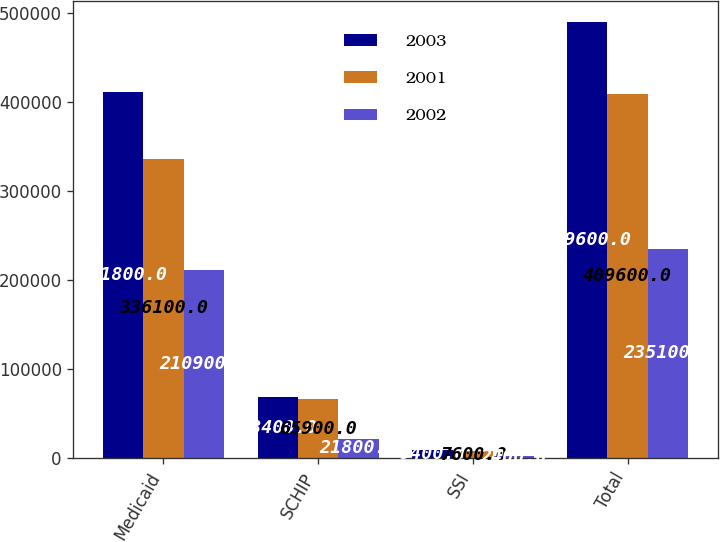Convert chart. <chart><loc_0><loc_0><loc_500><loc_500><stacked_bar_chart><ecel><fcel>Medicaid<fcel>SCHIP<fcel>SSI<fcel>Total<nl><fcel>2003<fcel>411800<fcel>68400<fcel>9400<fcel>489600<nl><fcel>2001<fcel>336100<fcel>65900<fcel>7600<fcel>409600<nl><fcel>2002<fcel>210900<fcel>21800<fcel>2400<fcel>235100<nl></chart> 